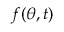<formula> <loc_0><loc_0><loc_500><loc_500>f ( \theta , t )</formula> 